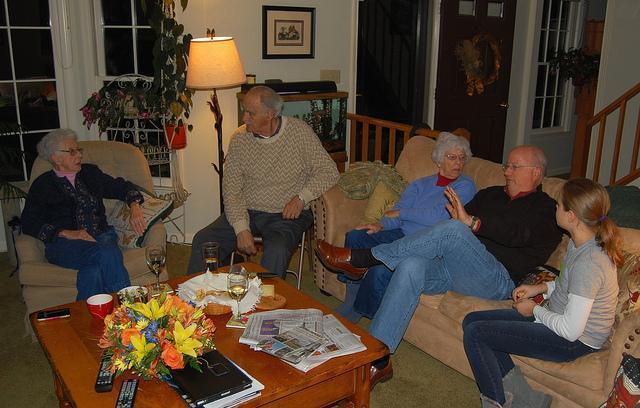How many women are wearing scarves?
Give a very brief answer. 0. How many people do you see?
Give a very brief answer. 5. How many people are in the picture?
Give a very brief answer. 5. How many people are there?
Give a very brief answer. 5. 